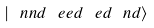<formula> <loc_0><loc_0><loc_500><loc_500>| \ n n d \ e e d \ e d \ n d \rangle</formula> 